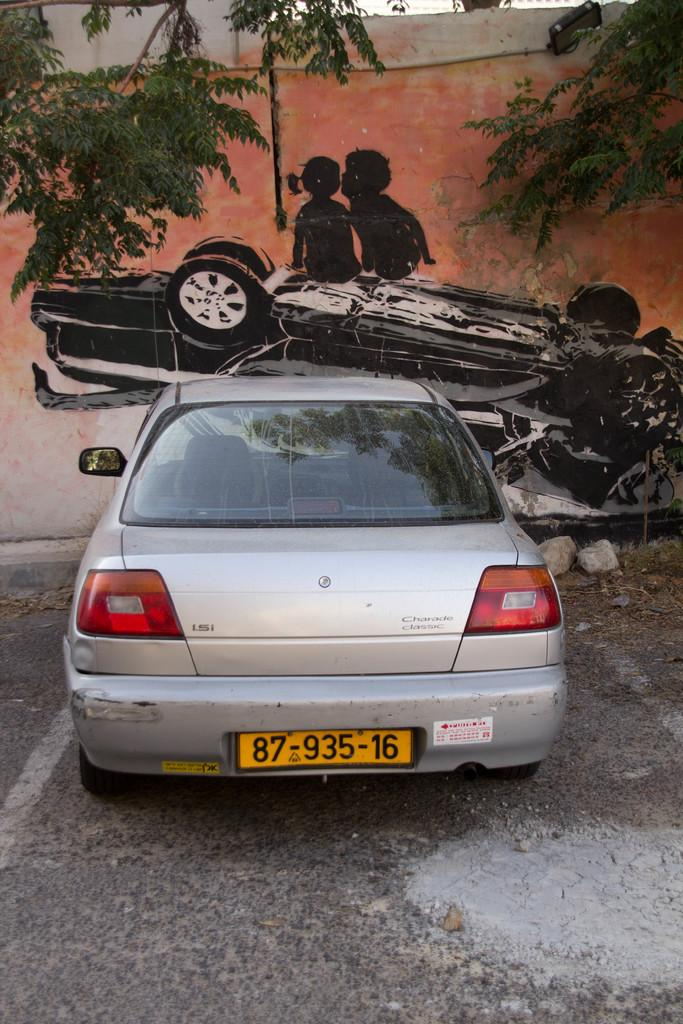What is the main subject of the image? There is a vehicle on the road in the image. What can be seen in the background of the image? There are trees and a painting visible in the background of the image. Can you describe the painting on the wall? The painting depicts two people and a vehicle. What position do the dogs hold in the government in the image? There are no dogs present in the image, so it is not possible to determine their position in the government. 